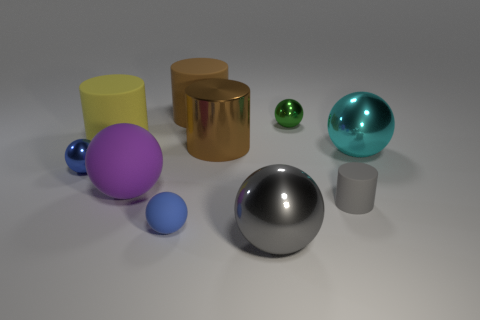Subtract all big metallic spheres. How many spheres are left? 4 Subtract all gray cylinders. How many cylinders are left? 3 Subtract all green balls. How many brown cylinders are left? 2 Subtract all green cylinders. Subtract all brown blocks. How many cylinders are left? 4 Add 2 large yellow rubber cylinders. How many large yellow rubber cylinders are left? 3 Add 9 brown balls. How many brown balls exist? 9 Subtract 0 cyan cylinders. How many objects are left? 10 Subtract all cylinders. How many objects are left? 6 Subtract all tiny red shiny cubes. Subtract all large gray shiny spheres. How many objects are left? 9 